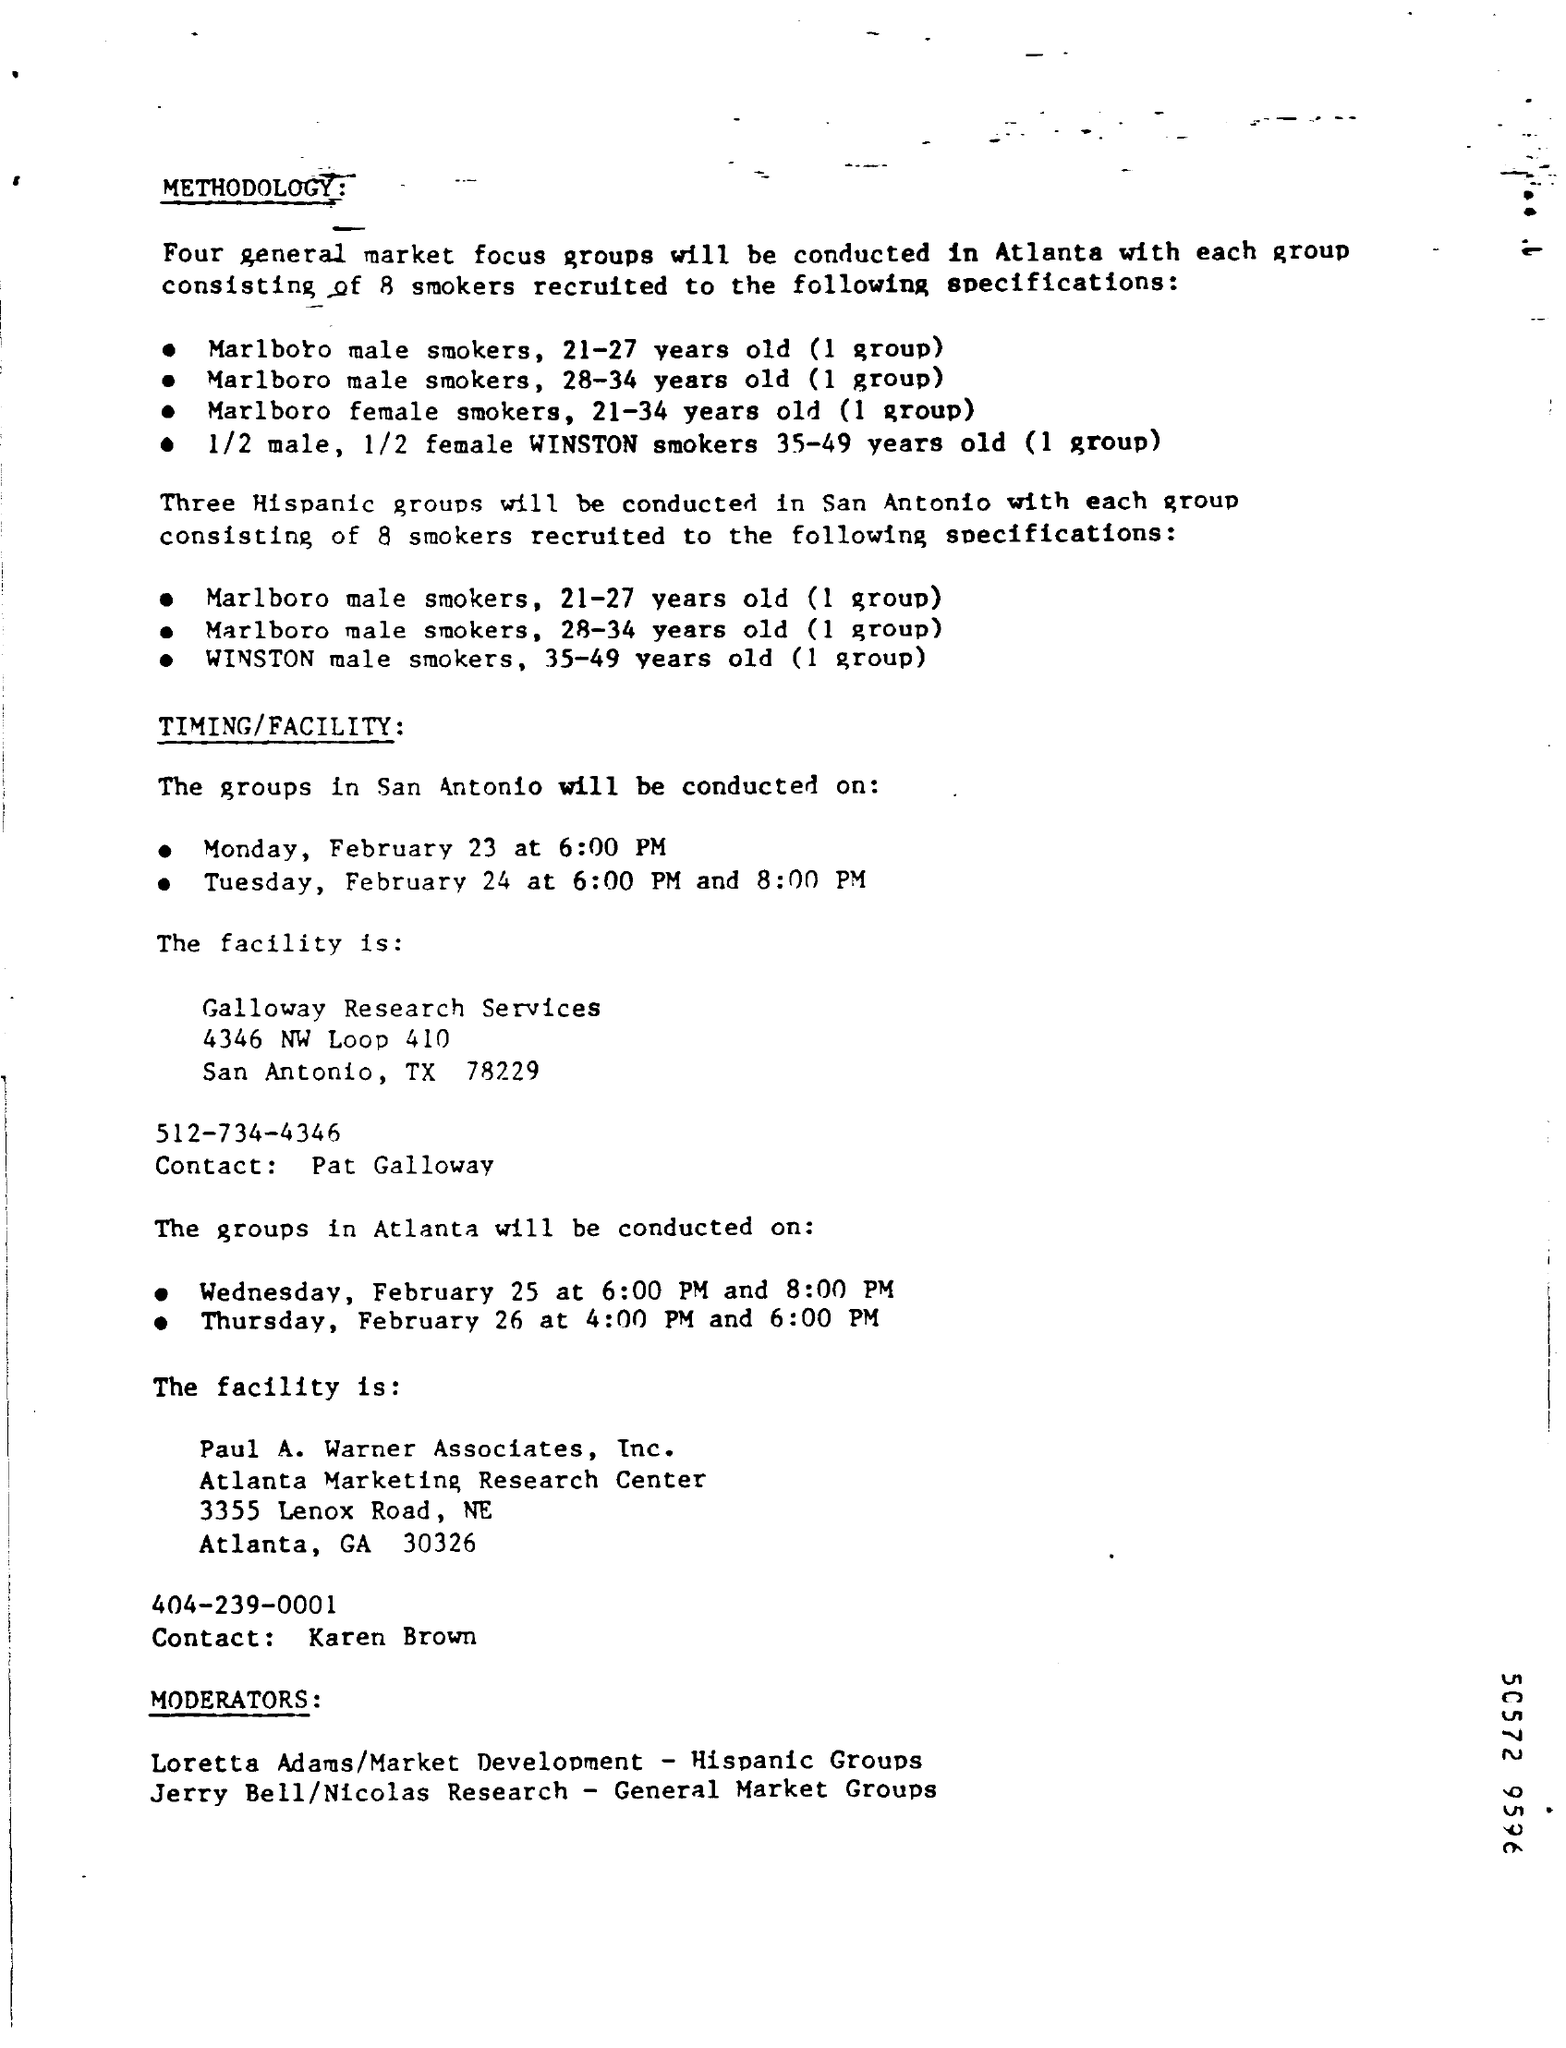Give some essential details in this illustration. The age group of Winston male smokers is 35 to 49 years old. On Monday, February 23, the groups in San Antonio will be conducted at 6:00 pm. 